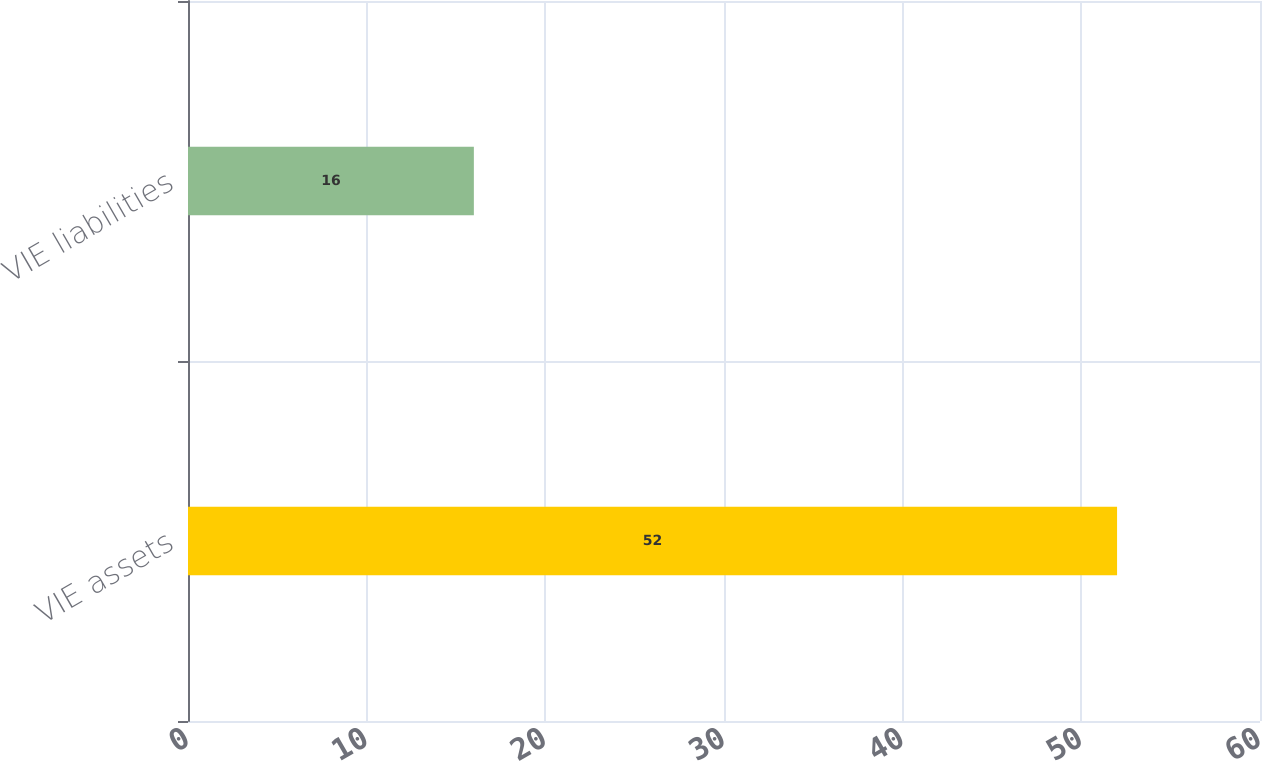Convert chart to OTSL. <chart><loc_0><loc_0><loc_500><loc_500><bar_chart><fcel>VIE assets<fcel>VIE liabilities<nl><fcel>52<fcel>16<nl></chart> 